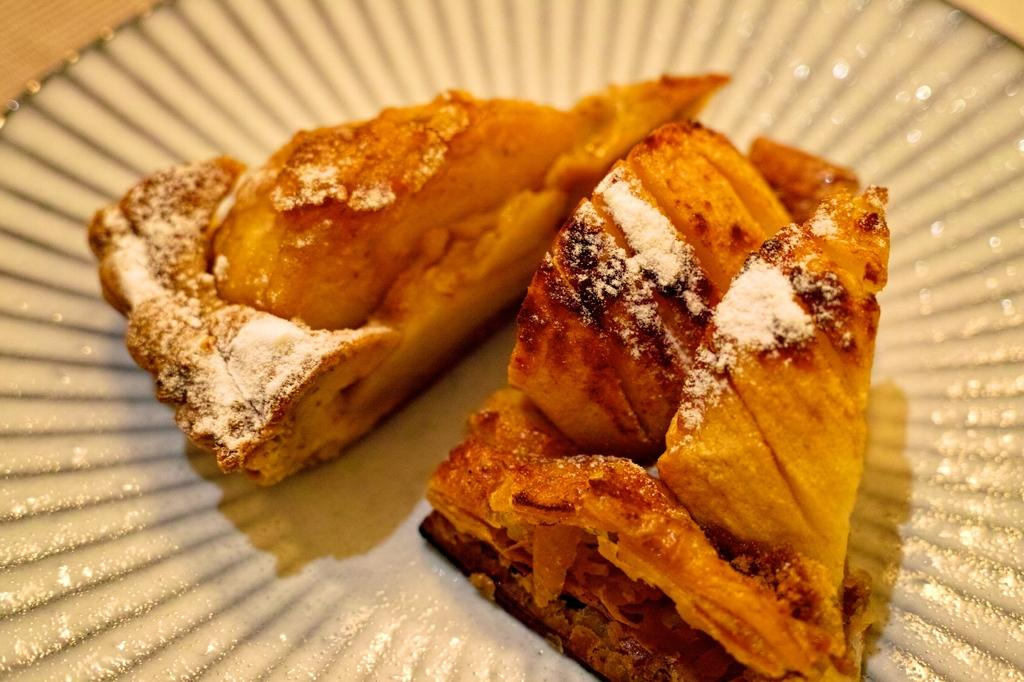What is the main subject of the image? There is a food item in the image. How is the food item presented in the image? The food item is in a plate. What type of worm can be seen crawling on the food item in the image? There is no worm present in the image. 